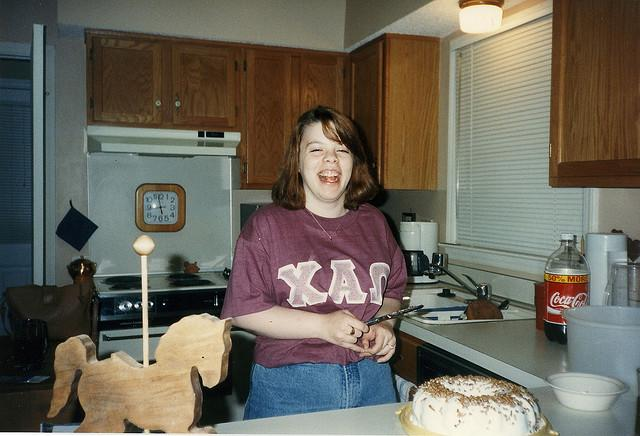What soda does she like to drink? coca cola 